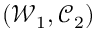Convert formula to latex. <formula><loc_0><loc_0><loc_500><loc_500>( \mathcal { W } _ { 1 } , \mathcal { C } _ { 2 } )</formula> 